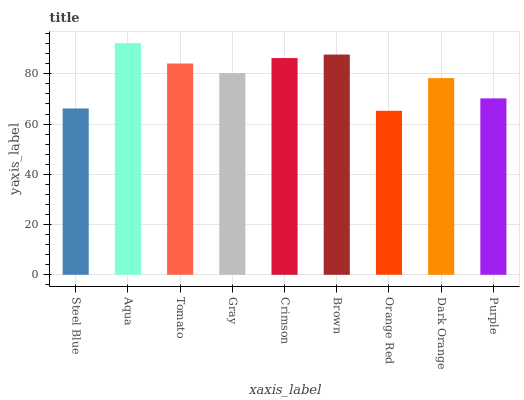Is Orange Red the minimum?
Answer yes or no. Yes. Is Aqua the maximum?
Answer yes or no. Yes. Is Tomato the minimum?
Answer yes or no. No. Is Tomato the maximum?
Answer yes or no. No. Is Aqua greater than Tomato?
Answer yes or no. Yes. Is Tomato less than Aqua?
Answer yes or no. Yes. Is Tomato greater than Aqua?
Answer yes or no. No. Is Aqua less than Tomato?
Answer yes or no. No. Is Gray the high median?
Answer yes or no. Yes. Is Gray the low median?
Answer yes or no. Yes. Is Steel Blue the high median?
Answer yes or no. No. Is Steel Blue the low median?
Answer yes or no. No. 